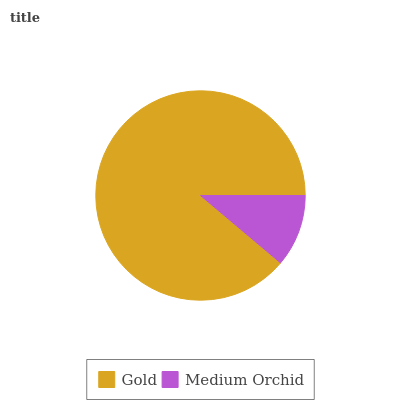Is Medium Orchid the minimum?
Answer yes or no. Yes. Is Gold the maximum?
Answer yes or no. Yes. Is Medium Orchid the maximum?
Answer yes or no. No. Is Gold greater than Medium Orchid?
Answer yes or no. Yes. Is Medium Orchid less than Gold?
Answer yes or no. Yes. Is Medium Orchid greater than Gold?
Answer yes or no. No. Is Gold less than Medium Orchid?
Answer yes or no. No. Is Gold the high median?
Answer yes or no. Yes. Is Medium Orchid the low median?
Answer yes or no. Yes. Is Medium Orchid the high median?
Answer yes or no. No. Is Gold the low median?
Answer yes or no. No. 